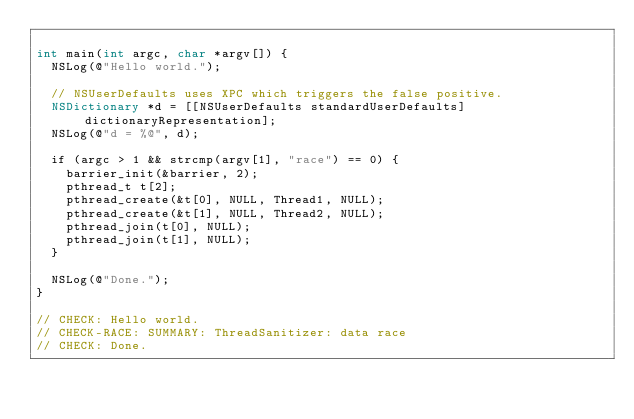<code> <loc_0><loc_0><loc_500><loc_500><_ObjectiveC_>
int main(int argc, char *argv[]) {
  NSLog(@"Hello world.");
  
  // NSUserDefaults uses XPC which triggers the false positive.
  NSDictionary *d = [[NSUserDefaults standardUserDefaults] dictionaryRepresentation];
  NSLog(@"d = %@", d);

  if (argc > 1 && strcmp(argv[1], "race") == 0) {
    barrier_init(&barrier, 2);
    pthread_t t[2];
    pthread_create(&t[0], NULL, Thread1, NULL);
    pthread_create(&t[1], NULL, Thread2, NULL);
    pthread_join(t[0], NULL);
    pthread_join(t[1], NULL);
  }

  NSLog(@"Done.");
}

// CHECK: Hello world.
// CHECK-RACE: SUMMARY: ThreadSanitizer: data race
// CHECK: Done.
</code> 